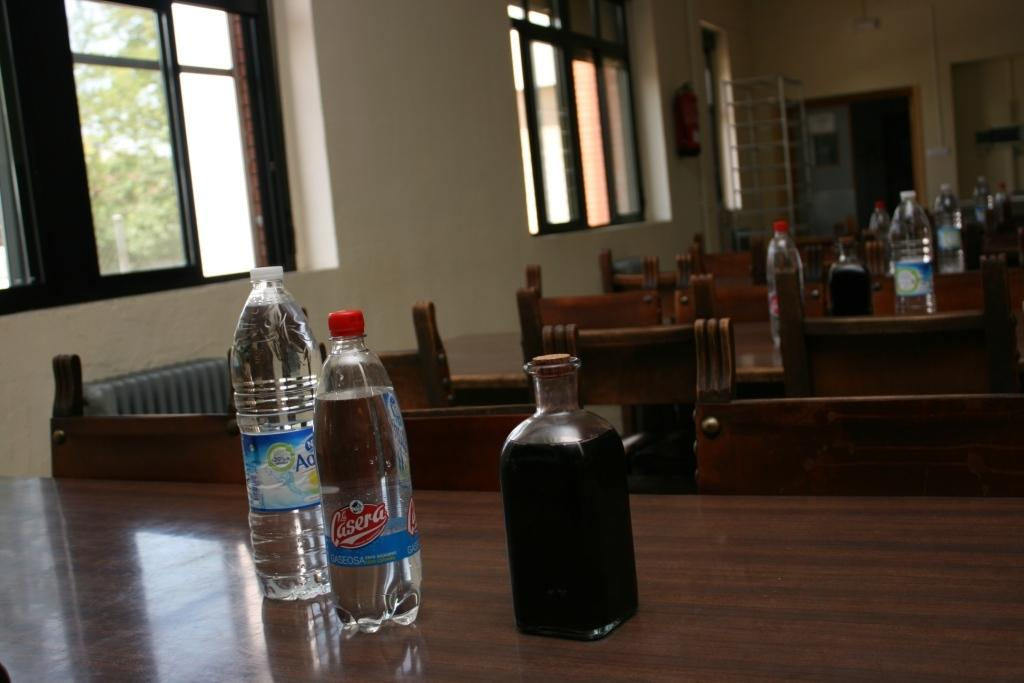What can be seen on the table in the image? There are water bottles on the table in the image. What type of furniture is visible in the image? There are chairs visible in the image. What is the background of the image composed of? There is a wall and a window in the image. What type of vegetation can be seen outside the window? There is a tree visible in the image. What theory is being discussed by the scarecrow in the image? There is no scarecrow present in the image, and therefore no discussion or theory can be observed. How does the tree in the image express anger? Trees do not express emotions like anger; they are inanimate objects. 